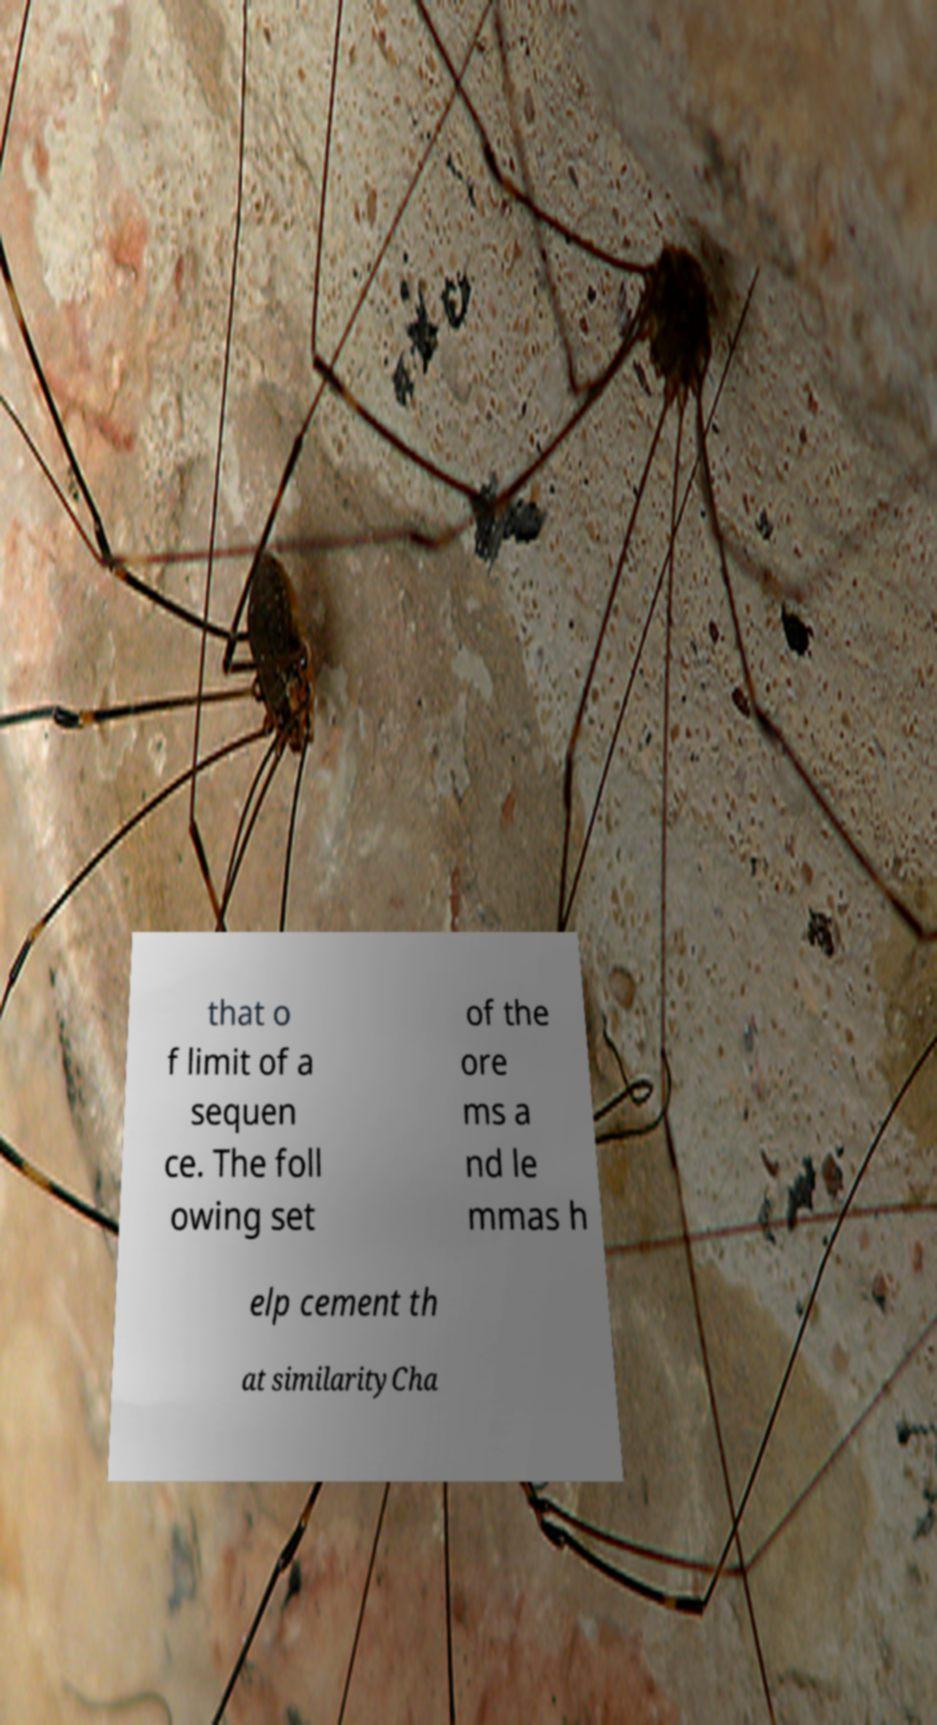There's text embedded in this image that I need extracted. Can you transcribe it verbatim? that o f limit of a sequen ce. The foll owing set of the ore ms a nd le mmas h elp cement th at similarityCha 